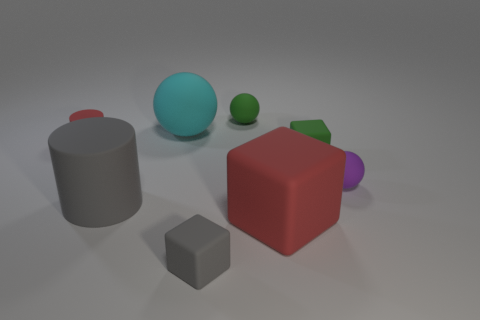Is the number of tiny matte spheres greater than the number of spheres?
Keep it short and to the point. No. There is a gray object that is the same size as the purple sphere; what is its material?
Ensure brevity in your answer.  Rubber. There is a rubber ball that is to the right of the green rubber block; is its size the same as the tiny gray matte cube?
Ensure brevity in your answer.  Yes. How many blocks are either large red matte objects or small red things?
Ensure brevity in your answer.  1. Are there fewer rubber blocks than big matte cylinders?
Give a very brief answer. No. How big is the thing that is in front of the small green rubber cube and right of the big red cube?
Give a very brief answer. Small. There is a block that is behind the rubber ball that is in front of the big matte thing behind the large cylinder; how big is it?
Provide a succinct answer. Small. What number of other things are there of the same color as the tiny cylinder?
Keep it short and to the point. 1. There is a small cube that is left of the big red matte block; is it the same color as the big rubber cylinder?
Give a very brief answer. Yes. What number of objects are large red objects or red cylinders?
Make the answer very short. 2. 